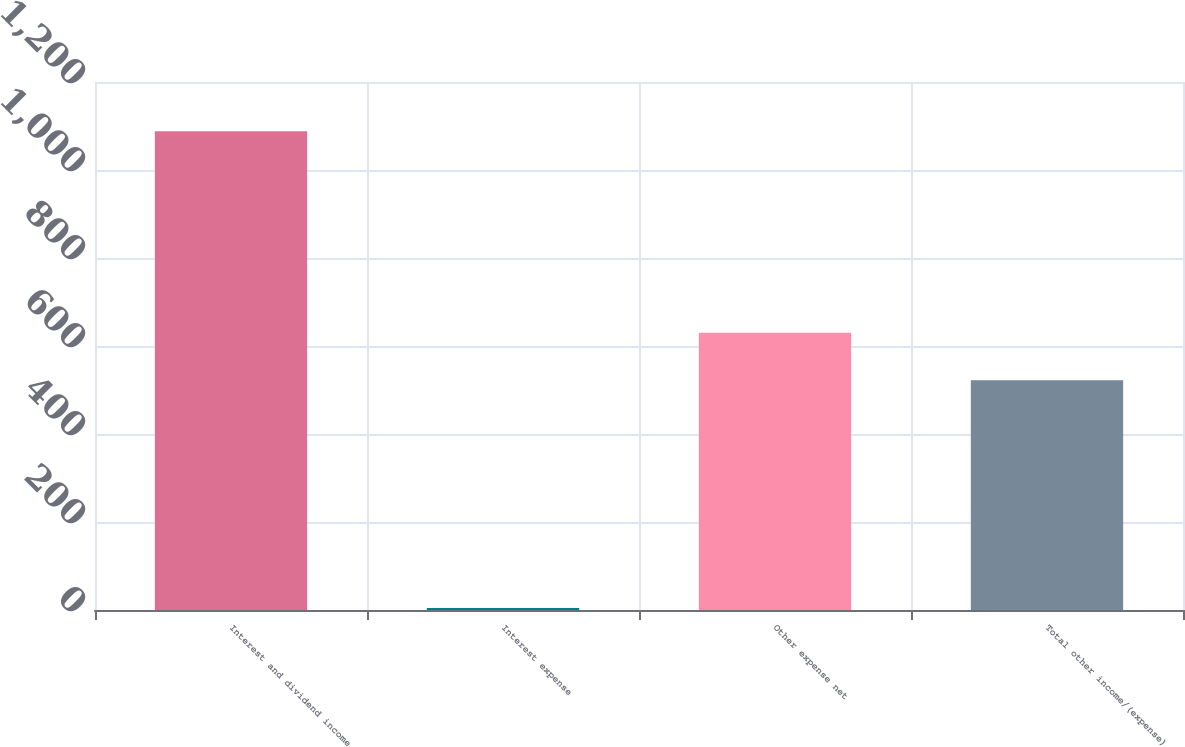Convert chart to OTSL. <chart><loc_0><loc_0><loc_500><loc_500><bar_chart><fcel>Interest and dividend income<fcel>Interest expense<fcel>Other expense net<fcel>Total other income/(expense)<nl><fcel>1088<fcel>4.54<fcel>630.35<fcel>522<nl></chart> 